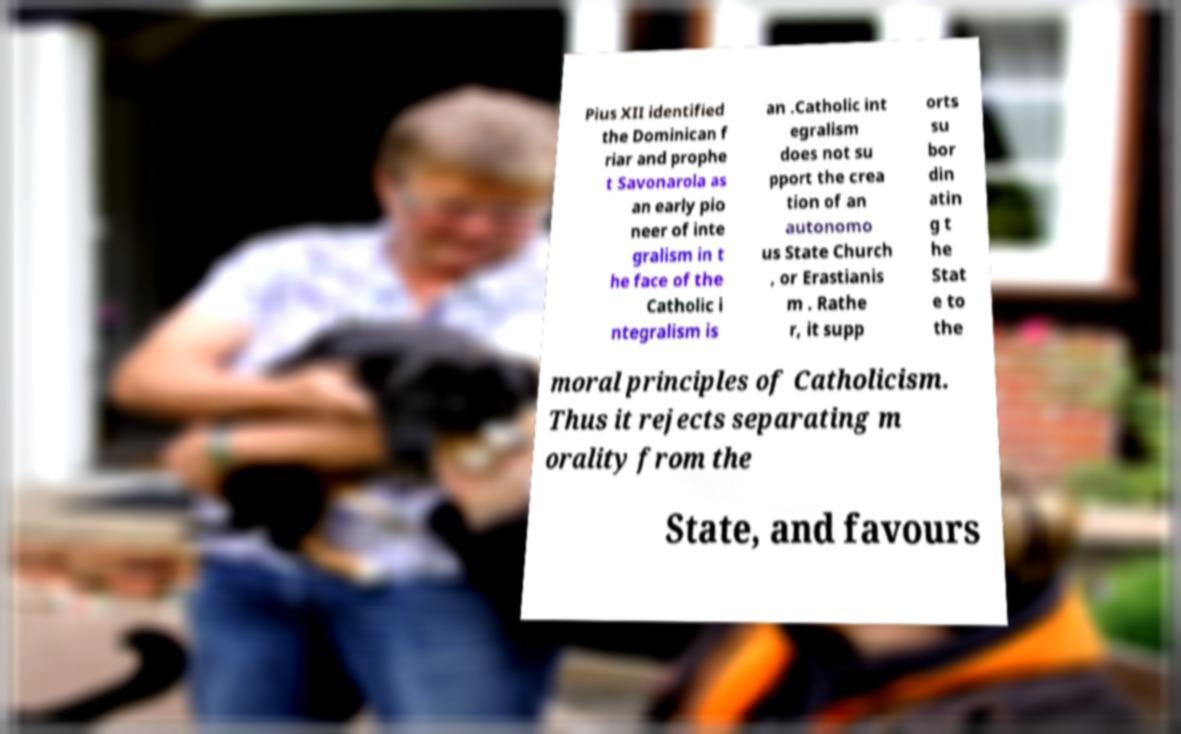Could you assist in decoding the text presented in this image and type it out clearly? Pius XII identified the Dominican f riar and prophe t Savonarola as an early pio neer of inte gralism in t he face of the Catholic i ntegralism is an .Catholic int egralism does not su pport the crea tion of an autonomo us State Church , or Erastianis m . Rathe r, it supp orts su bor din atin g t he Stat e to the moral principles of Catholicism. Thus it rejects separating m orality from the State, and favours 